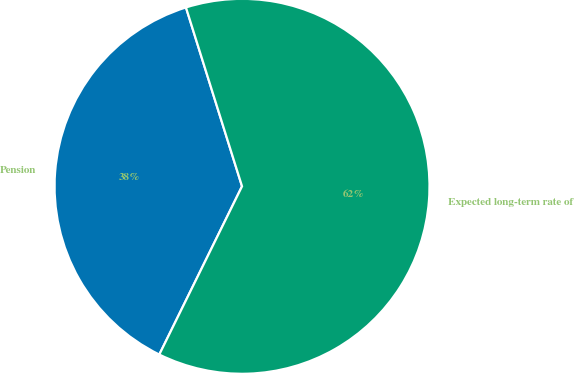Convert chart. <chart><loc_0><loc_0><loc_500><loc_500><pie_chart><fcel>Pension<fcel>Expected long-term rate of<nl><fcel>37.89%<fcel>62.11%<nl></chart> 